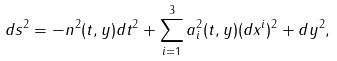<formula> <loc_0><loc_0><loc_500><loc_500>d s ^ { 2 } = - n ^ { 2 } ( t , y ) d t ^ { 2 } + \sum _ { i = 1 } ^ { 3 } a _ { i } ^ { 2 } ( t , y ) ( d x ^ { i } ) ^ { 2 } + d y ^ { 2 } ,</formula> 